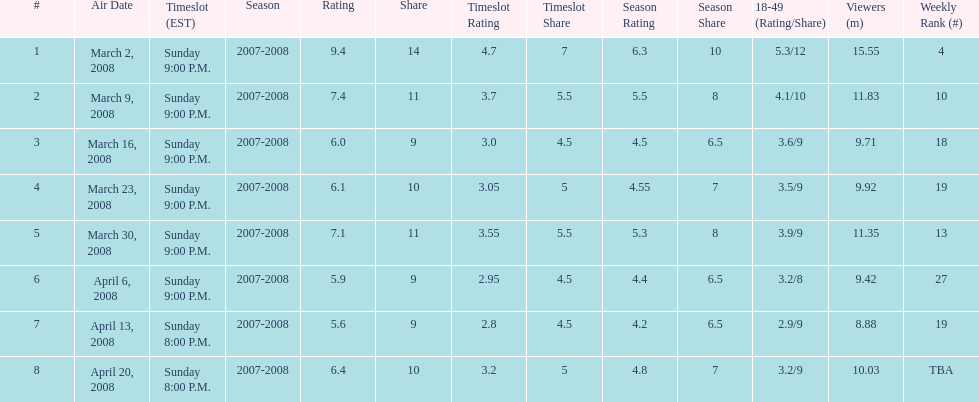The air date with the most viewers March 2, 2008. 